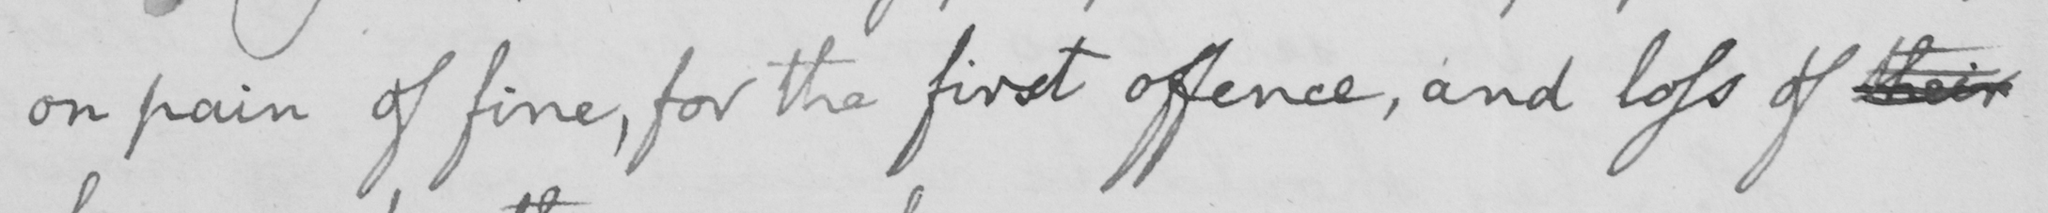Transcribe the text shown in this historical manuscript line. on pain of fine , for the first offence , and loss of their 